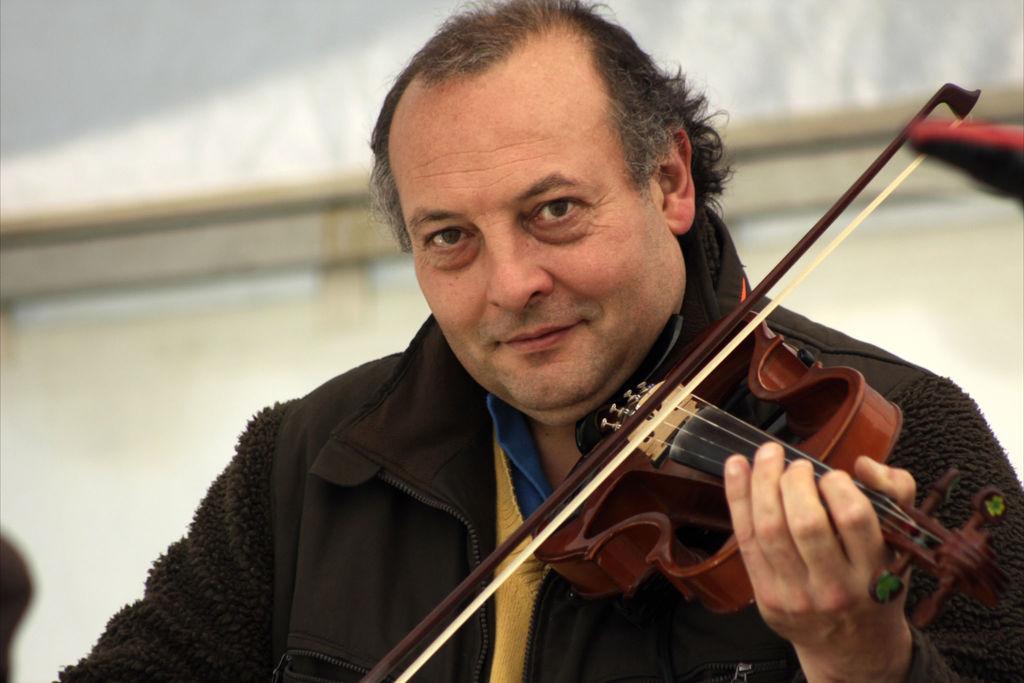How would you summarize this image in a sentence or two? This man is playing a violin and wore jacket. 